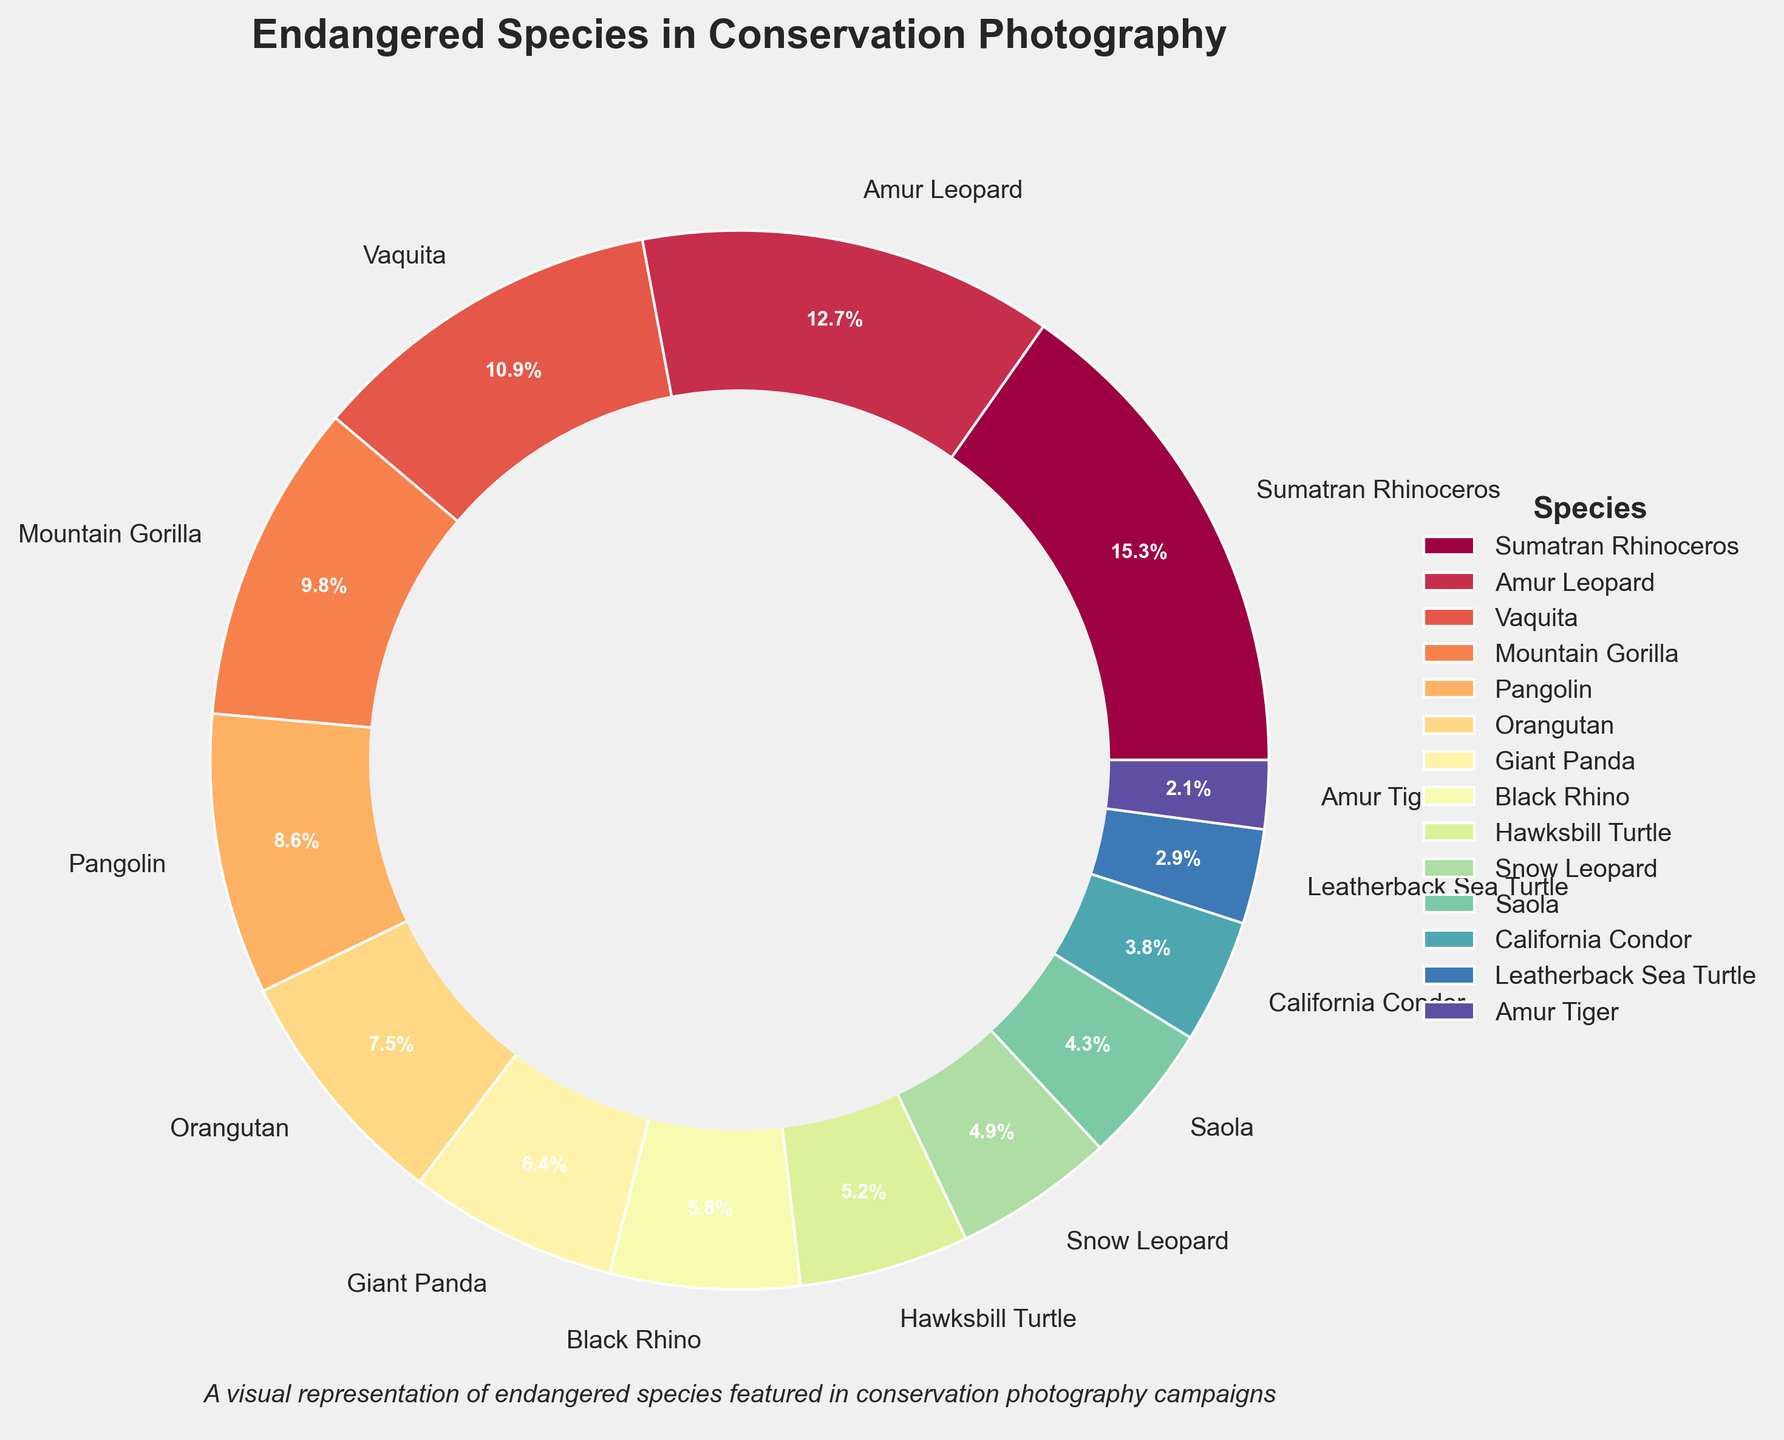What's the percentage representation of the Sumatran Rhinoceros and Amur Leopard combined? To find the combined percentage of the Sumatran Rhinoceros and Amur Leopard, add their individual percentages: 15.3% + 12.7% = 28.0%
Answer: 28.0% Which species features the least in the conservation photography campaigns? The species with the smallest percentage on the pie chart is the Amur Tiger with 2.1%.
Answer: Amur Tiger Between the Vaquita and Mountain Gorilla, which species is more featured in the campaigns? Comparing their percentages, Vaquita has 10.9% while Mountain Gorilla has 9.8%. Therefore, Vaquita is more featured.
Answer: Vaquita How much more is the percentage of Orangutan compared to Leatherback Sea Turtle? Subtract the Leatherback Sea Turtle's percentage from the Orangutan's percentage: 7.5% - 2.9% = 4.6%
Answer: 4.6% Among the species listed, which have a percentage less than 5%? The species with percentages less than 5% are Snow Leopard (4.9%), Saola (4.3%), California Condor (3.8%), Leatherback Sea Turtle (2.9%), and Amur Tiger (2.1%).
Answer: Snow Leopard, Saola, California Condor, Leatherback Sea Turtle, Amur Tiger What is the total percentage of species featured that are turtles? Add the percentages of Hawksbill Turtle and Leatherback Sea Turtle: 5.2% + 2.9% = 8.1%
Answer: 8.1% If we combine the percentages of Pangolin and Giant Panda, would it surpass the percentage of Sumatran Rhinoceros? Add the percentages of Pangolin and Giant Panda: 8.6% + 6.4% = 15.0%. The combined percentage is less than Sumatran Rhinoceros' 15.3%.
Answer: No Which species falls exactly in the middle percentage-wise when all species are ordered by their percentages? Ordering all species by percentages, the middle species is Pangolin with 8.6% as there are 14 species in total, and Pangolin is the 7th when sorted.
Answer: Pangolin Is the difference in percentage between the Amur Leopard and Giant Panda more than 6%? Subtract the Giant Panda's percentage from the Amur Leopard's: 12.7% - 6.4% = 6.3%. The difference is indeed more than 6%.
Answer: Yes 